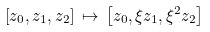<formula> <loc_0><loc_0><loc_500><loc_500>\left [ z _ { 0 } , z _ { 1 } , z _ { 2 } \right ] \, \mapsto \, \left [ z _ { 0 } , \xi z _ { 1 } , \xi ^ { 2 } z _ { 2 } \right ]</formula> 